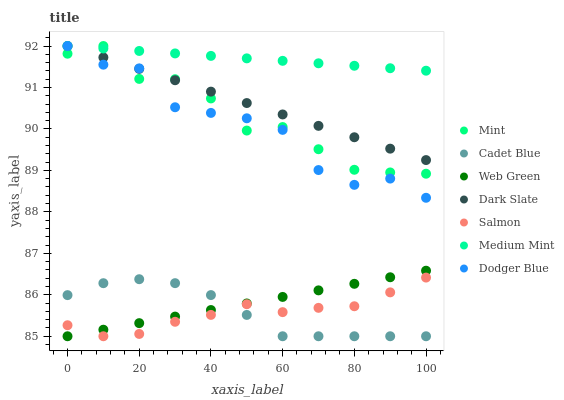Does Salmon have the minimum area under the curve?
Answer yes or no. Yes. Does Medium Mint have the maximum area under the curve?
Answer yes or no. Yes. Does Cadet Blue have the minimum area under the curve?
Answer yes or no. No. Does Cadet Blue have the maximum area under the curve?
Answer yes or no. No. Is Dark Slate the smoothest?
Answer yes or no. Yes. Is Dodger Blue the roughest?
Answer yes or no. Yes. Is Cadet Blue the smoothest?
Answer yes or no. No. Is Cadet Blue the roughest?
Answer yes or no. No. Does Cadet Blue have the lowest value?
Answer yes or no. Yes. Does Dark Slate have the lowest value?
Answer yes or no. No. Does Mint have the highest value?
Answer yes or no. Yes. Does Salmon have the highest value?
Answer yes or no. No. Is Cadet Blue less than Medium Mint?
Answer yes or no. Yes. Is Dark Slate greater than Web Green?
Answer yes or no. Yes. Does Web Green intersect Salmon?
Answer yes or no. Yes. Is Web Green less than Salmon?
Answer yes or no. No. Is Web Green greater than Salmon?
Answer yes or no. No. Does Cadet Blue intersect Medium Mint?
Answer yes or no. No. 